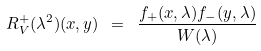<formula> <loc_0><loc_0><loc_500><loc_500>R _ { V } ^ { + } ( \lambda ^ { 2 } ) ( x , y ) \ = \ \frac { f _ { + } ( x , \lambda ) f _ { - } ( y , \lambda ) } { W ( \lambda ) }</formula> 